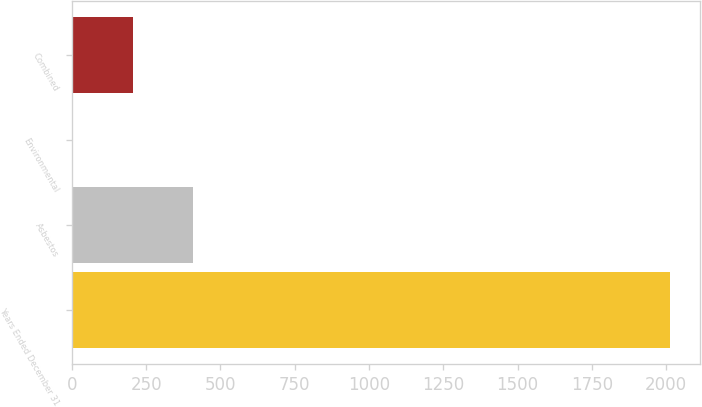Convert chart. <chart><loc_0><loc_0><loc_500><loc_500><bar_chart><fcel>Years Ended December 31<fcel>Asbestos<fcel>Environmental<fcel>Combined<nl><fcel>2012<fcel>405.92<fcel>4.4<fcel>205.16<nl></chart> 